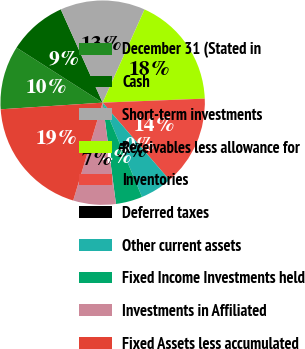<chart> <loc_0><loc_0><loc_500><loc_500><pie_chart><fcel>December 31 (Stated in<fcel>Cash<fcel>Short-term investments<fcel>Receivables less allowance for<fcel>Inventories<fcel>Deferred taxes<fcel>Other current assets<fcel>Fixed Income Investments held<fcel>Investments in Affiliated<fcel>Fixed Assets less accumulated<nl><fcel>10.08%<fcel>9.24%<fcel>13.44%<fcel>17.64%<fcel>14.28%<fcel>0.01%<fcel>5.05%<fcel>4.21%<fcel>6.73%<fcel>19.31%<nl></chart> 